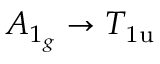<formula> <loc_0><loc_0><loc_500><loc_500>A _ { 1 _ { g } } \rightarrow T _ { 1 u }</formula> 